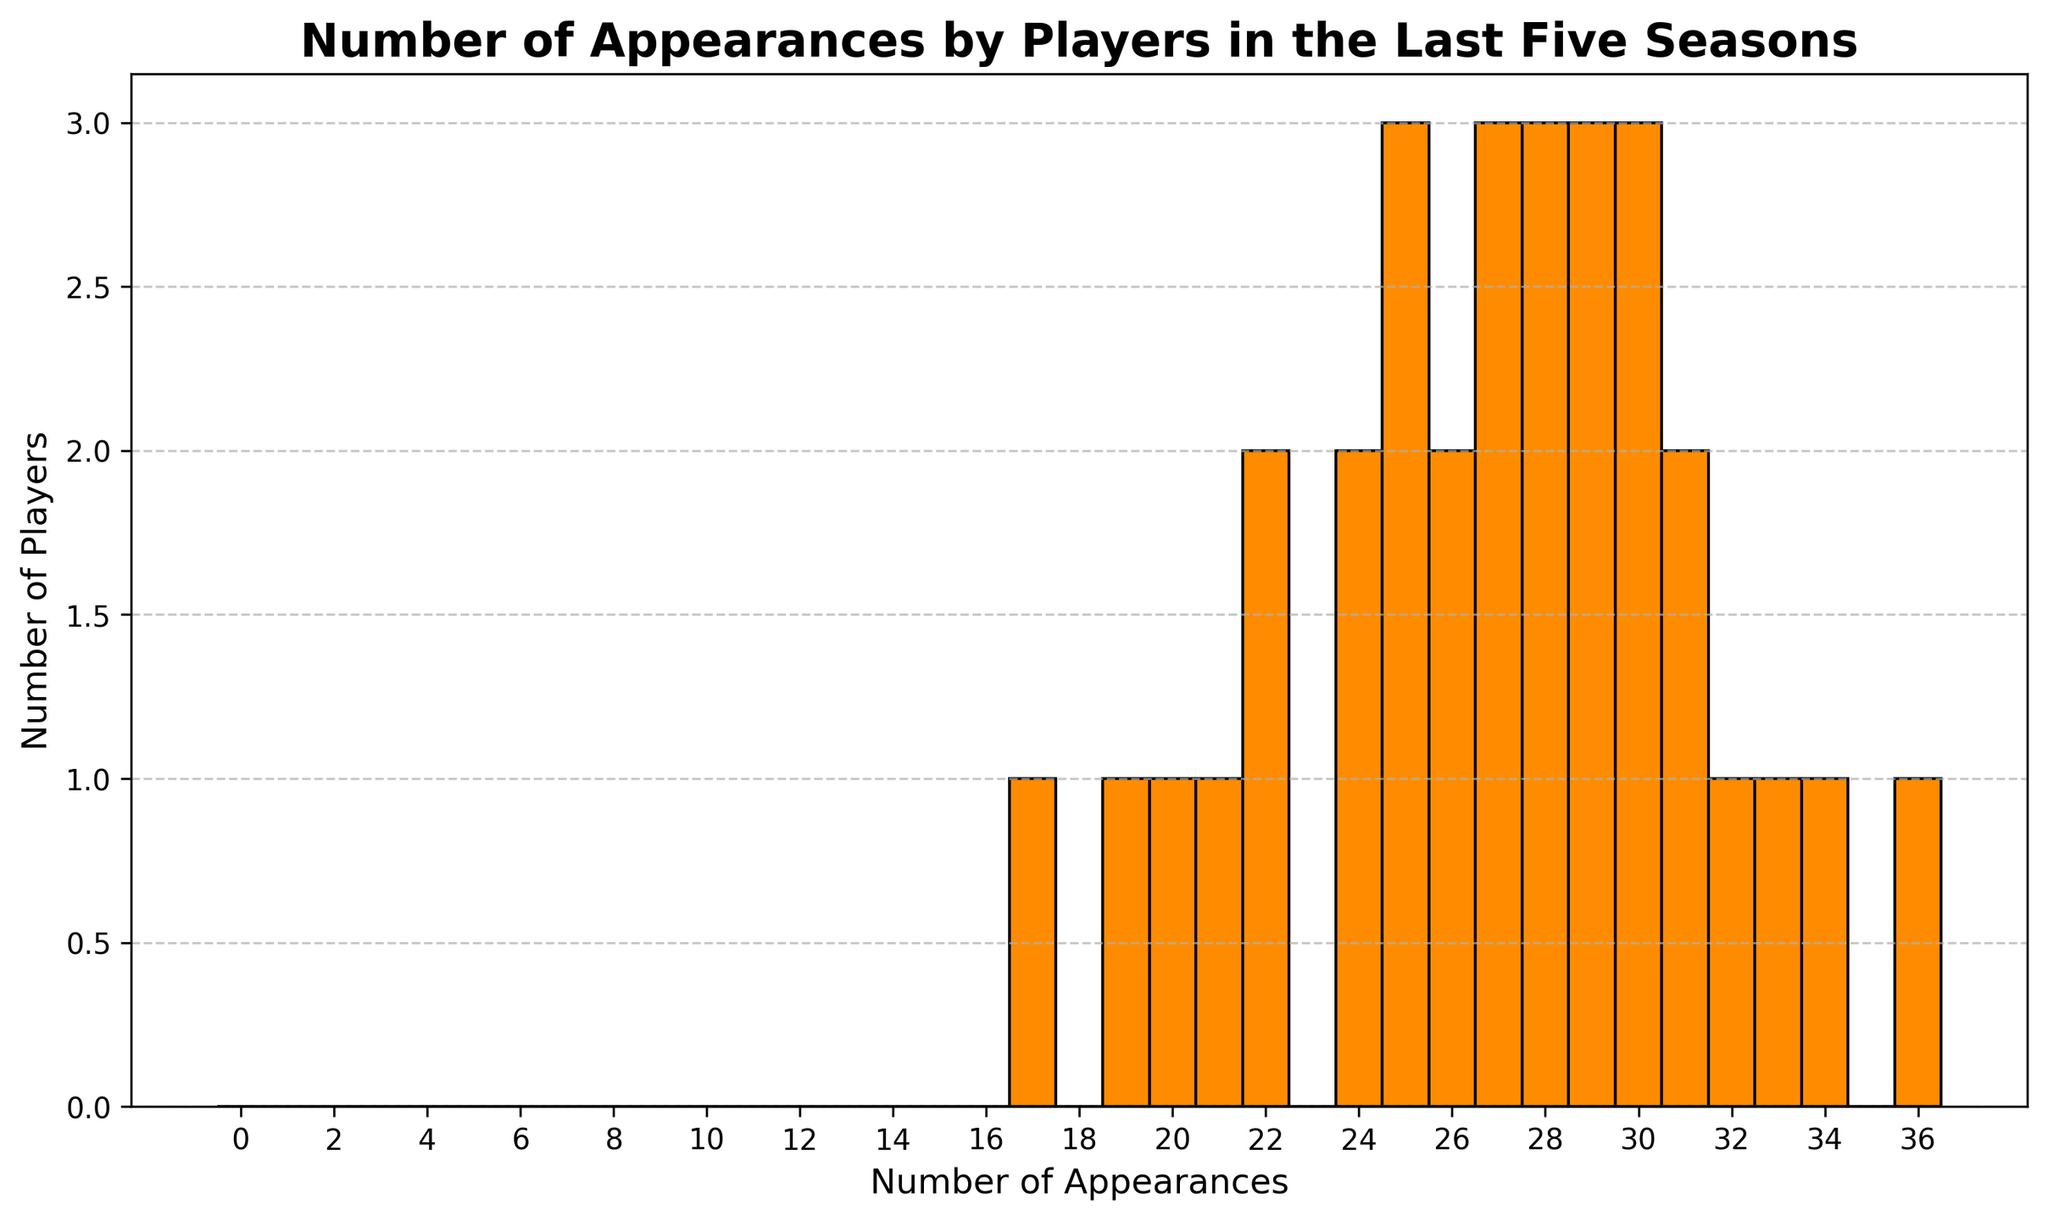Which number of appearances has the highest number of players? Observing the histogram, the bar with the greatest height corresponds to the number of appearances that the most players have.
Answer: 30 How many players have made exactly 25 appearances? By checking the bar height above '25' on the x-axis, we can see how many players made 25 appearances.
Answer: 3 What is the total number of players who made fewer than 30 appearances? Add the frequencies of all bars corresponding to fewer than 30 appearances: 17, 19, 20, 21, 22, 24, 25, 26, 27, 28, and 29.
Answer: 14 Compare the number of players who made more than 30 appearances with those who made less than 30 appearances. Which group is larger? Count the players for each group and compare the totals. More than 30 appearances: 5 players (31, 32, 33, 34, and 36); Less than 30 appearances: 14 players.
Answer: Less than 30 What is the range of the number of player appearances? The range is calculated as the difference between the highest and lowest appearances shown on the x-axis. The lowest is 17, and the highest is 36.
Answer: 19 How many players made exactly 28 appearances? Examine the height of the bar at '28' on the x-axis to determine the count.
Answer: 3 Which number of appearances has the second most players? Identify the height of the second highest bar after determining the highest.
Answer: 31 What percentage of players made at least 30 appearances? First, count the total number of players (19), then determine how many made at least 30 appearances (6), and calculate the percentage: (6/19)*100%.
Answer: ~32% Is the number of players who made 22 appearances greater than or less than those who made 29 appearances? Compare the heights of the bars for 22 appearances and 29 appearances.
Answer: Less than 